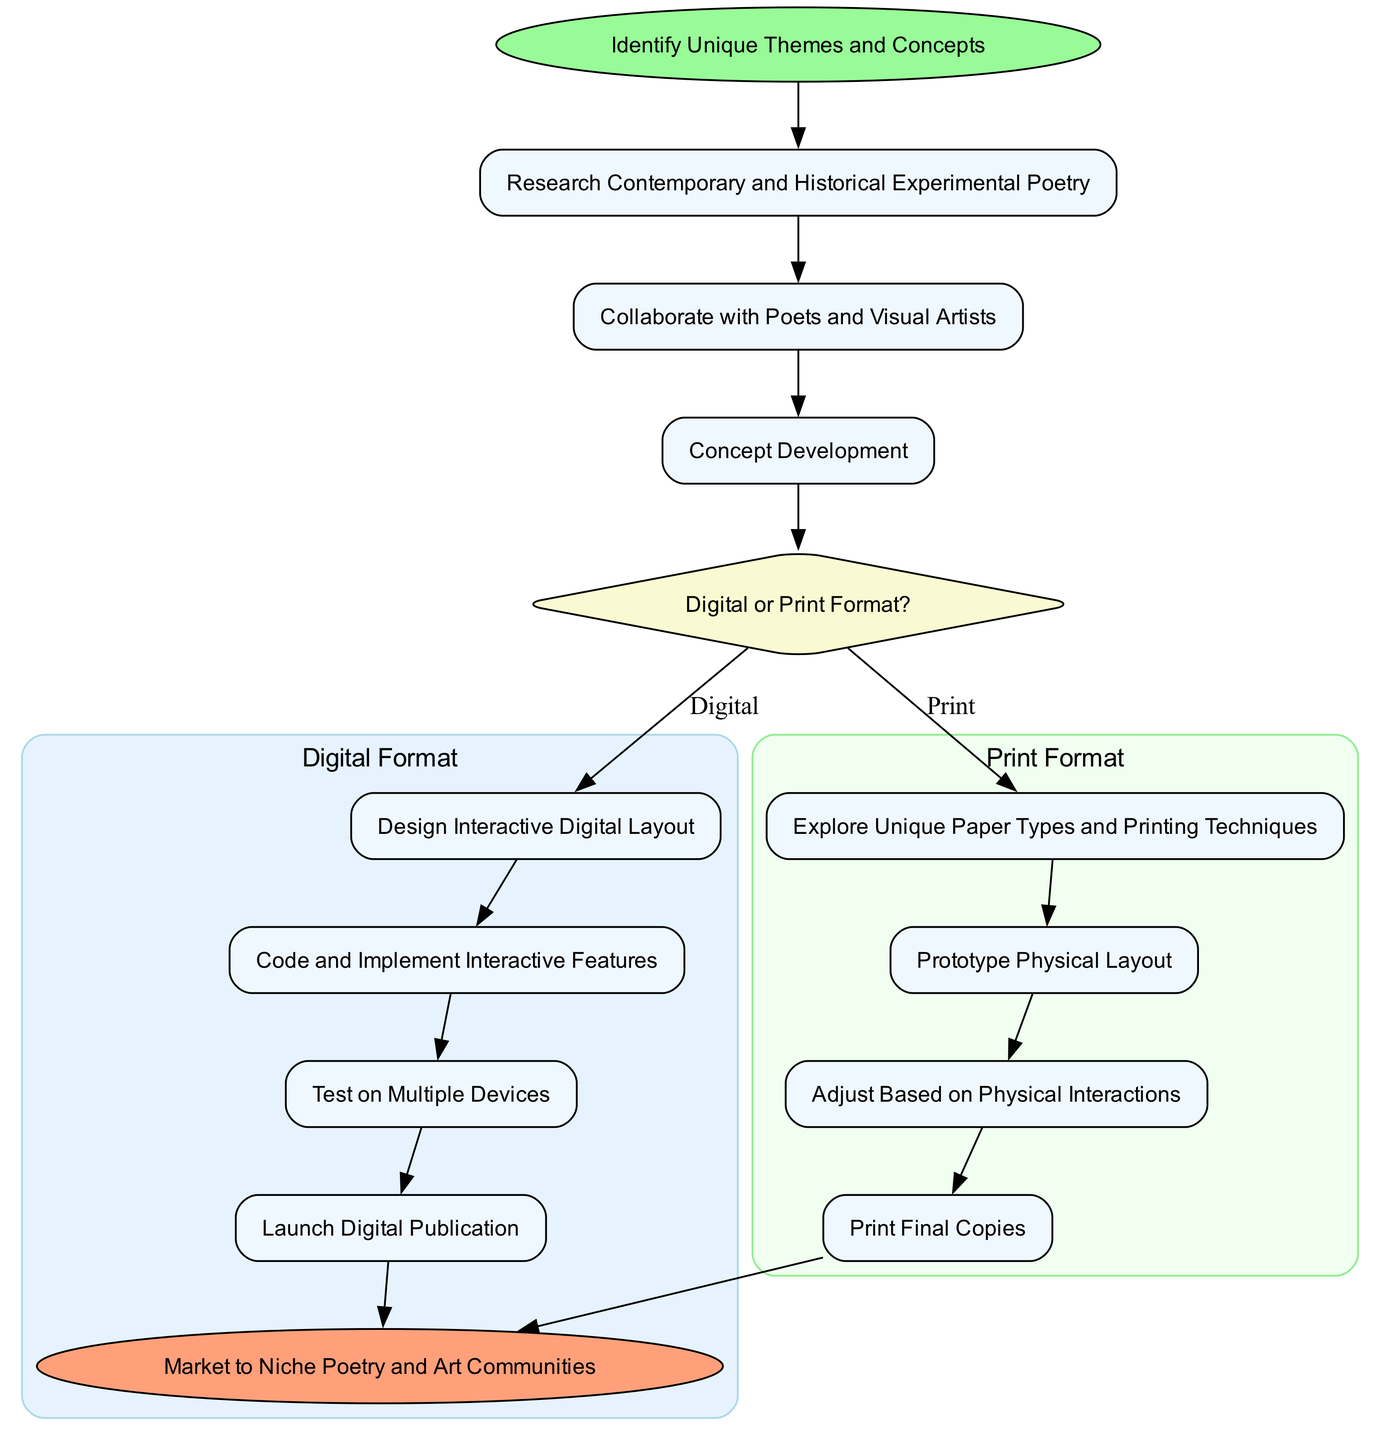What is the first step in the process? The diagram indicates that the first step is "Research Contemporary and Historical Experimental Poetry" which directly follows the "Start" node.
Answer: Research Contemporary and Historical Experimental Poetry How many steps are there in the process before the decision point? The steps listed before the decision point are three: "Research Contemporary and Historical Experimental Poetry," "Collaborate with Poets and Visual Artists," and "Concept Development." Thus, there are three steps.
Answer: 3 What is the decision point after the initial steps? The decision point in the diagram is labeled "Digital or Print Format?" which follows "Concept Development" indicating a choice between two formats.
Answer: Digital or Print Format? What are the two branches after the decision point? After the decision point, the two branches are "Digital Format" and "Print Format," distinguishing the paths for creating the poetry publication.
Answer: Digital Format and Print Format List one step in the digital format branch. The digital format branch includes several steps; one of them is "Design Interactive Digital Layout." This is the first step specifically outlined in the digital branch.
Answer: Design Interactive Digital Layout What is the final step for the print format branch? The last step in the print format branch is "Print Final Copies," which culminates the process for the print format.
Answer: Print Final Copies What do both branches lead to after their final steps? Both the digital and print format branches conclude with an edge that leads to the "End" node, which indicates the ultimate goal of the process.
Answer: Market to Niche Poetry and Art Communities How many total steps are there in the digital format path? The digital format path consists of four steps: "Design Interactive Digital Layout," "Code and Implement Interactive Features," "Test on Multiple Devices," and "Launch Digital Publication," totaling four steps.
Answer: 4 What step in the print format involves adjustments based on interactions? In the print format branch, "Adjust Based on Physical Interactions" is the step that involves making adjustments based on user interactions with the physical publication.
Answer: Adjust Based on Physical Interactions 